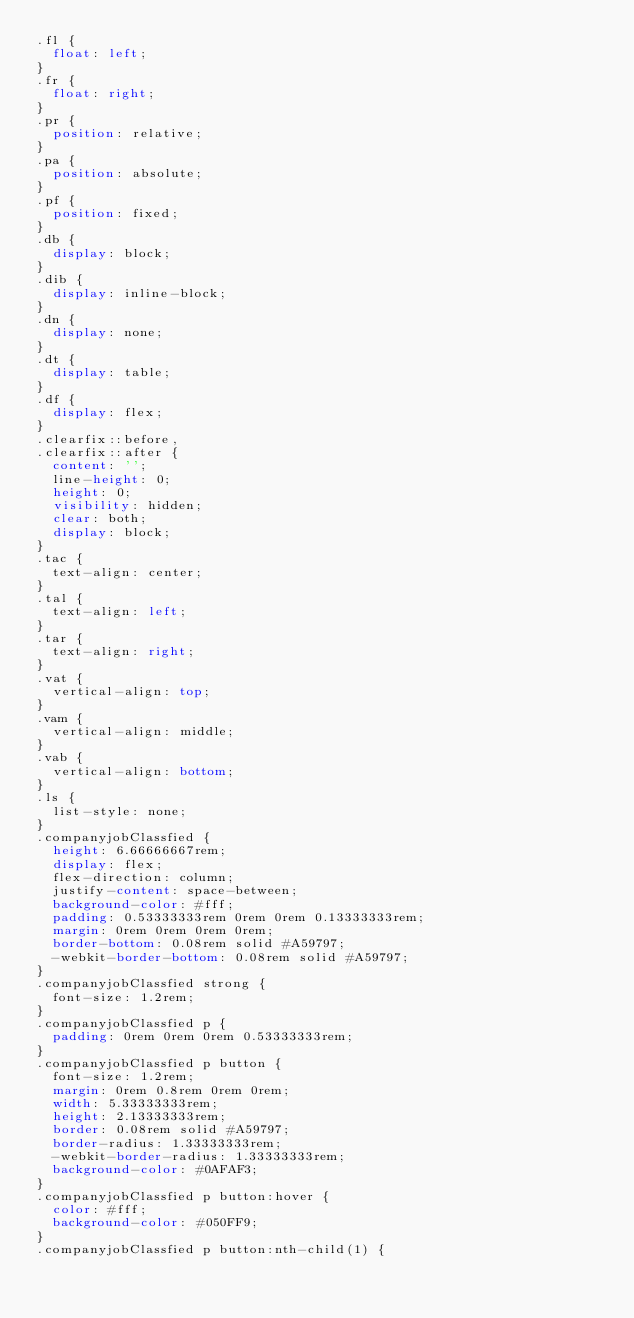Convert code to text. <code><loc_0><loc_0><loc_500><loc_500><_CSS_>.fl {
  float: left;
}
.fr {
  float: right;
}
.pr {
  position: relative;
}
.pa {
  position: absolute;
}
.pf {
  position: fixed;
}
.db {
  display: block;
}
.dib {
  display: inline-block;
}
.dn {
  display: none;
}
.dt {
  display: table;
}
.df {
  display: flex;
}
.clearfix::before,
.clearfix::after {
  content: '';
  line-height: 0;
  height: 0;
  visibility: hidden;
  clear: both;
  display: block;
}
.tac {
  text-align: center;
}
.tal {
  text-align: left;
}
.tar {
  text-align: right;
}
.vat {
  vertical-align: top;
}
.vam {
  vertical-align: middle;
}
.vab {
  vertical-align: bottom;
}
.ls {
  list-style: none;
}
.companyjobClassfied {
  height: 6.66666667rem;
  display: flex;
  flex-direction: column;
  justify-content: space-between;
  background-color: #fff;
  padding: 0.53333333rem 0rem 0rem 0.13333333rem;
  margin: 0rem 0rem 0rem 0rem;
  border-bottom: 0.08rem solid #A59797;
  -webkit-border-bottom: 0.08rem solid #A59797;
}
.companyjobClassfied strong {
  font-size: 1.2rem;
}
.companyjobClassfied p {
  padding: 0rem 0rem 0rem 0.53333333rem;
}
.companyjobClassfied p button {
  font-size: 1.2rem;
  margin: 0rem 0.8rem 0rem 0rem;
  width: 5.33333333rem;
  height: 2.13333333rem;
  border: 0.08rem solid #A59797;
  border-radius: 1.33333333rem;
  -webkit-border-radius: 1.33333333rem;
  background-color: #0AFAF3;
}
.companyjobClassfied p button:hover {
  color: #fff;
  background-color: #050FF9;
}
.companyjobClassfied p button:nth-child(1) {</code> 